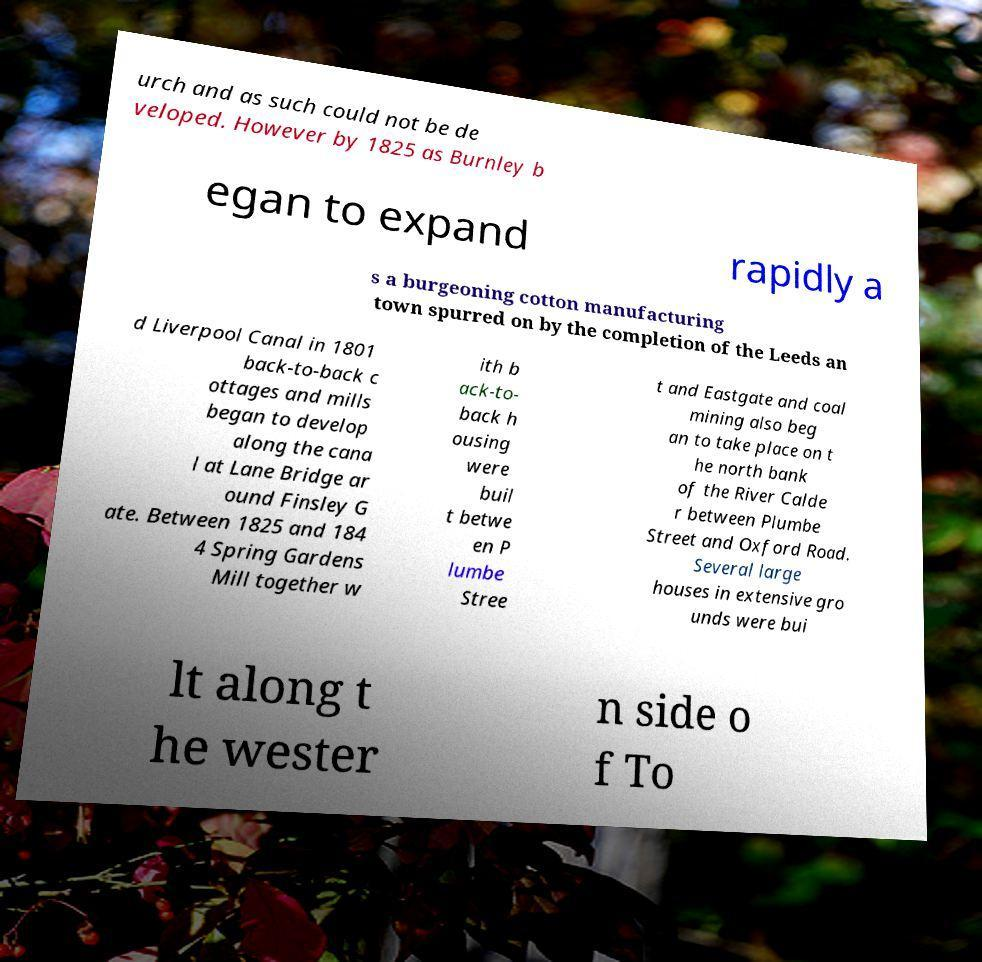Please identify and transcribe the text found in this image. urch and as such could not be de veloped. However by 1825 as Burnley b egan to expand rapidly a s a burgeoning cotton manufacturing town spurred on by the completion of the Leeds an d Liverpool Canal in 1801 back-to-back c ottages and mills began to develop along the cana l at Lane Bridge ar ound Finsley G ate. Between 1825 and 184 4 Spring Gardens Mill together w ith b ack-to- back h ousing were buil t betwe en P lumbe Stree t and Eastgate and coal mining also beg an to take place on t he north bank of the River Calde r between Plumbe Street and Oxford Road. Several large houses in extensive gro unds were bui lt along t he wester n side o f To 